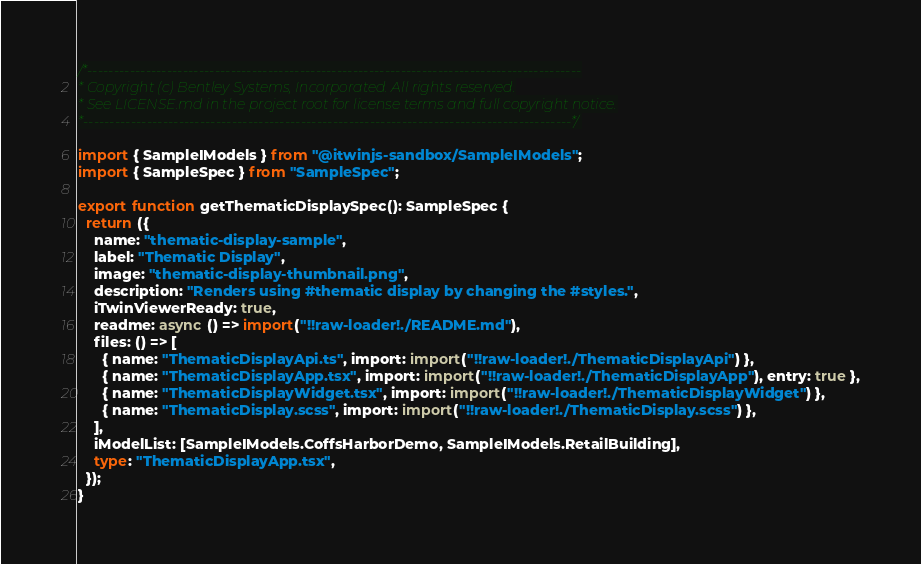Convert code to text. <code><loc_0><loc_0><loc_500><loc_500><_TypeScript_>/*---------------------------------------------------------------------------------------------
* Copyright (c) Bentley Systems, Incorporated. All rights reserved.
* See LICENSE.md in the project root for license terms and full copyright notice.
*--------------------------------------------------------------------------------------------*/

import { SampleIModels } from "@itwinjs-sandbox/SampleIModels";
import { SampleSpec } from "SampleSpec";

export function getThematicDisplaySpec(): SampleSpec {
  return ({
    name: "thematic-display-sample",
    label: "Thematic Display",
    image: "thematic-display-thumbnail.png",
    description: "Renders using #thematic display by changing the #styles.",
    iTwinViewerReady: true,
    readme: async () => import("!!raw-loader!./README.md"),
    files: () => [
      { name: "ThematicDisplayApi.ts", import: import("!!raw-loader!./ThematicDisplayApi") },
      { name: "ThematicDisplayApp.tsx", import: import("!!raw-loader!./ThematicDisplayApp"), entry: true },
      { name: "ThematicDisplayWidget.tsx", import: import("!!raw-loader!./ThematicDisplayWidget") },
      { name: "ThematicDisplay.scss", import: import("!!raw-loader!./ThematicDisplay.scss") },
    ],
    iModelList: [SampleIModels.CoffsHarborDemo, SampleIModels.RetailBuilding],
    type: "ThematicDisplayApp.tsx",
  });
}
</code> 